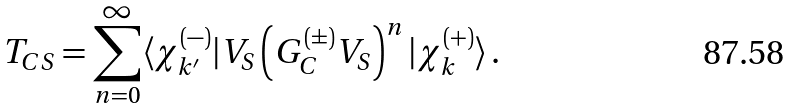Convert formula to latex. <formula><loc_0><loc_0><loc_500><loc_500>T _ { C S } = \sum _ { n = 0 } ^ { \infty } \langle \chi ^ { ( - ) } _ { k ^ { \prime } } | V _ { S } \left ( G _ { C } ^ { ( \pm ) } V _ { S } \right ) ^ { n } | \chi ^ { ( + ) } _ { k } \rangle \, .</formula> 